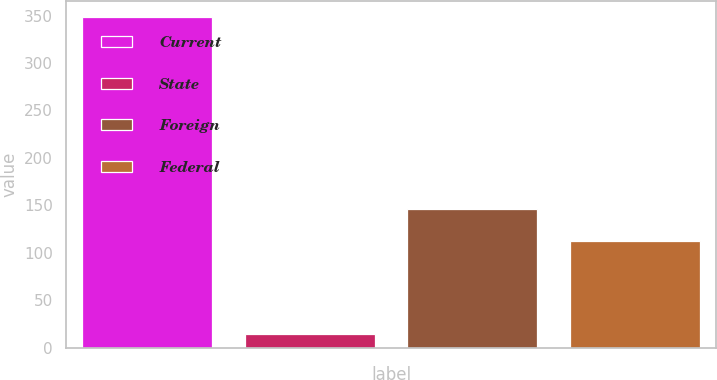<chart> <loc_0><loc_0><loc_500><loc_500><bar_chart><fcel>Current<fcel>State<fcel>Foreign<fcel>Federal<nl><fcel>348<fcel>14<fcel>146<fcel>112<nl></chart> 